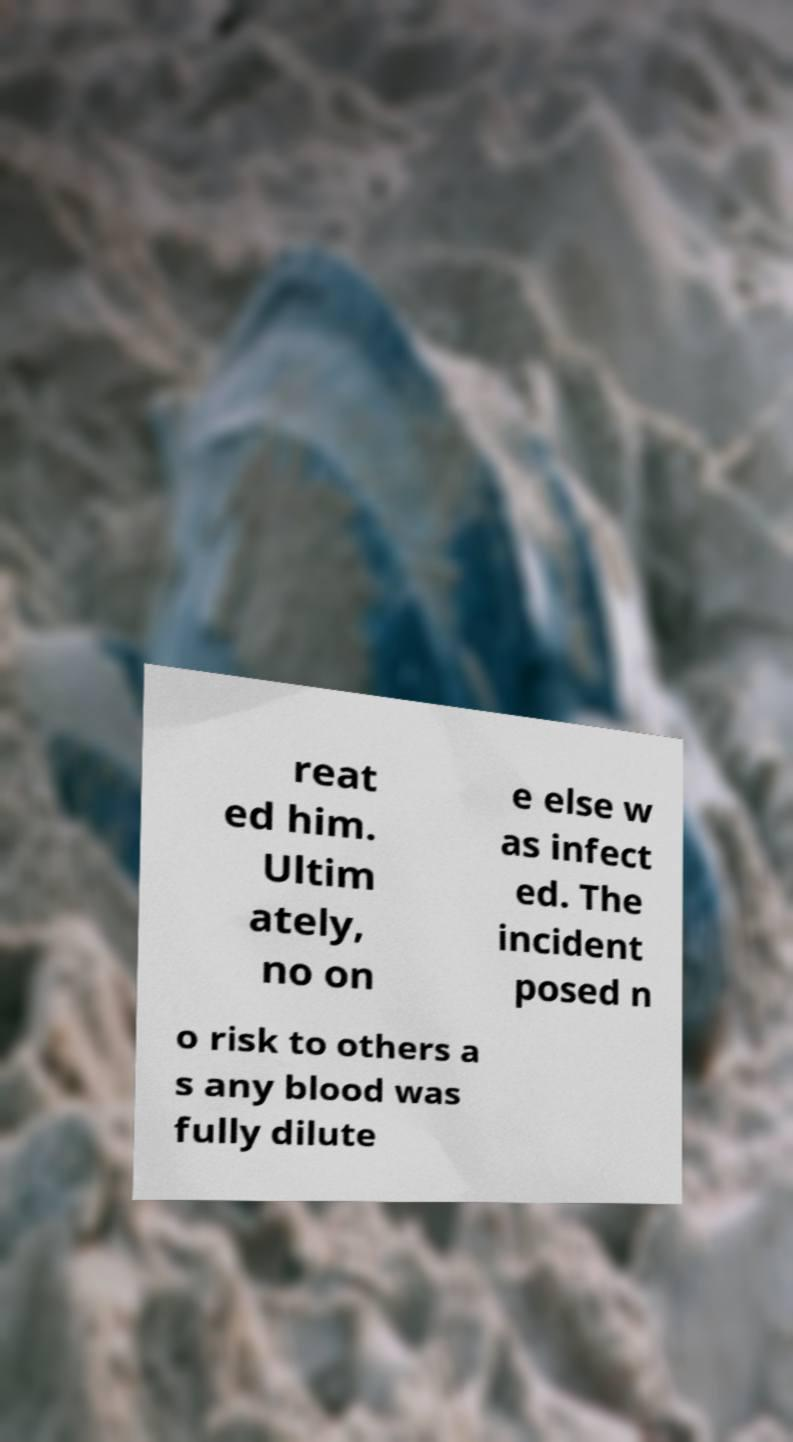Can you accurately transcribe the text from the provided image for me? reat ed him. Ultim ately, no on e else w as infect ed. The incident posed n o risk to others a s any blood was fully dilute 